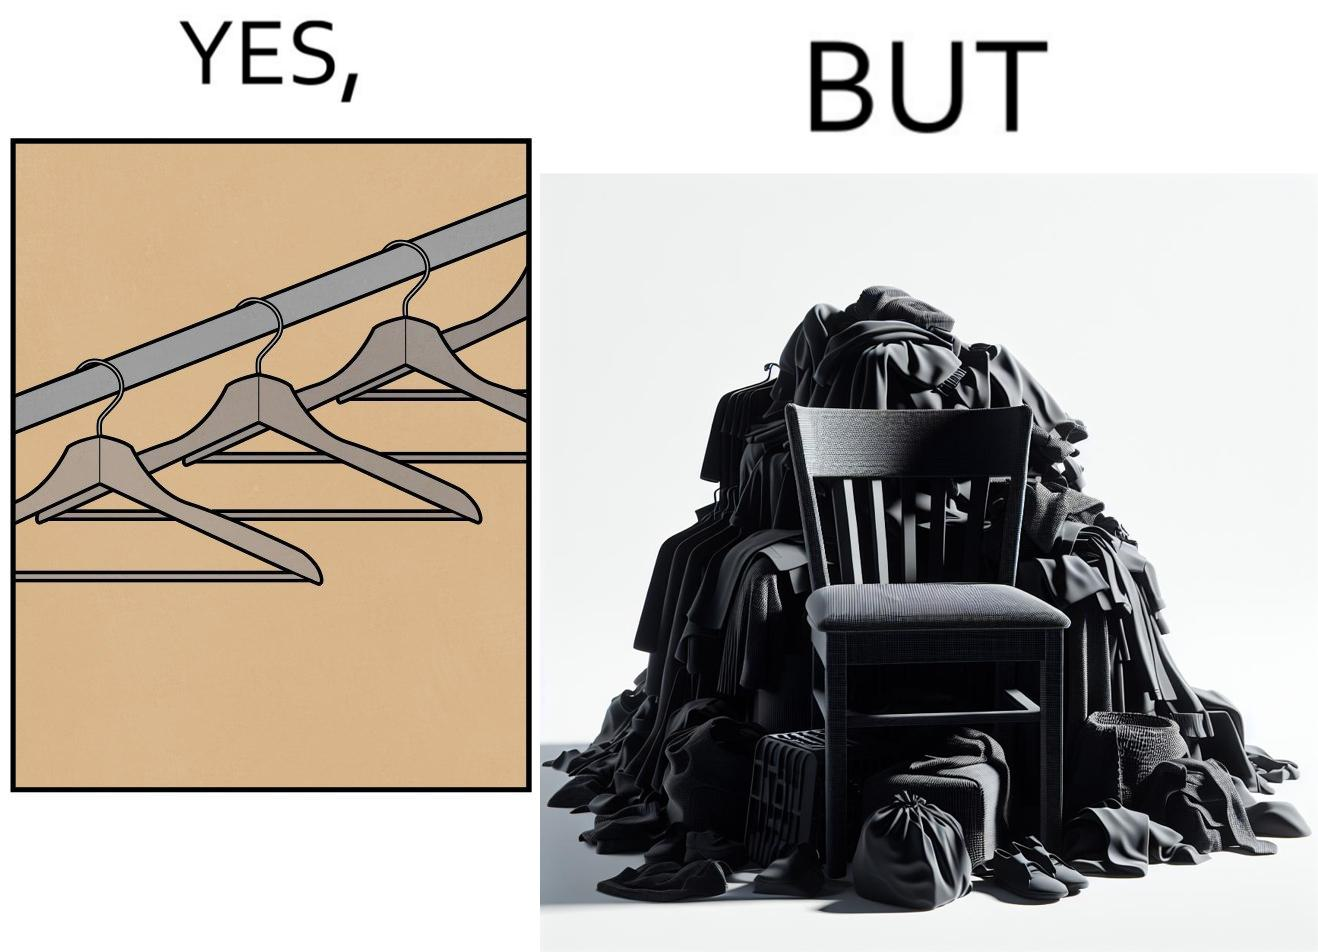Does this image contain satire or humor? Yes, this image is satirical. 